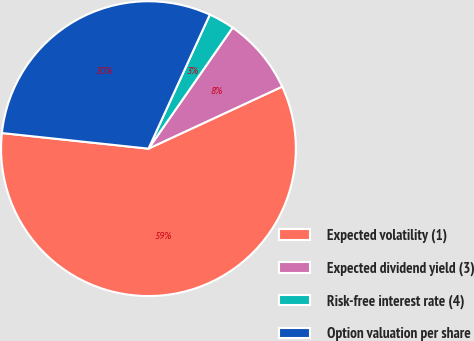<chart> <loc_0><loc_0><loc_500><loc_500><pie_chart><fcel>Expected volatility (1)<fcel>Expected dividend yield (3)<fcel>Risk-free interest rate (4)<fcel>Option valuation per share<nl><fcel>58.6%<fcel>8.42%<fcel>2.84%<fcel>30.14%<nl></chart> 